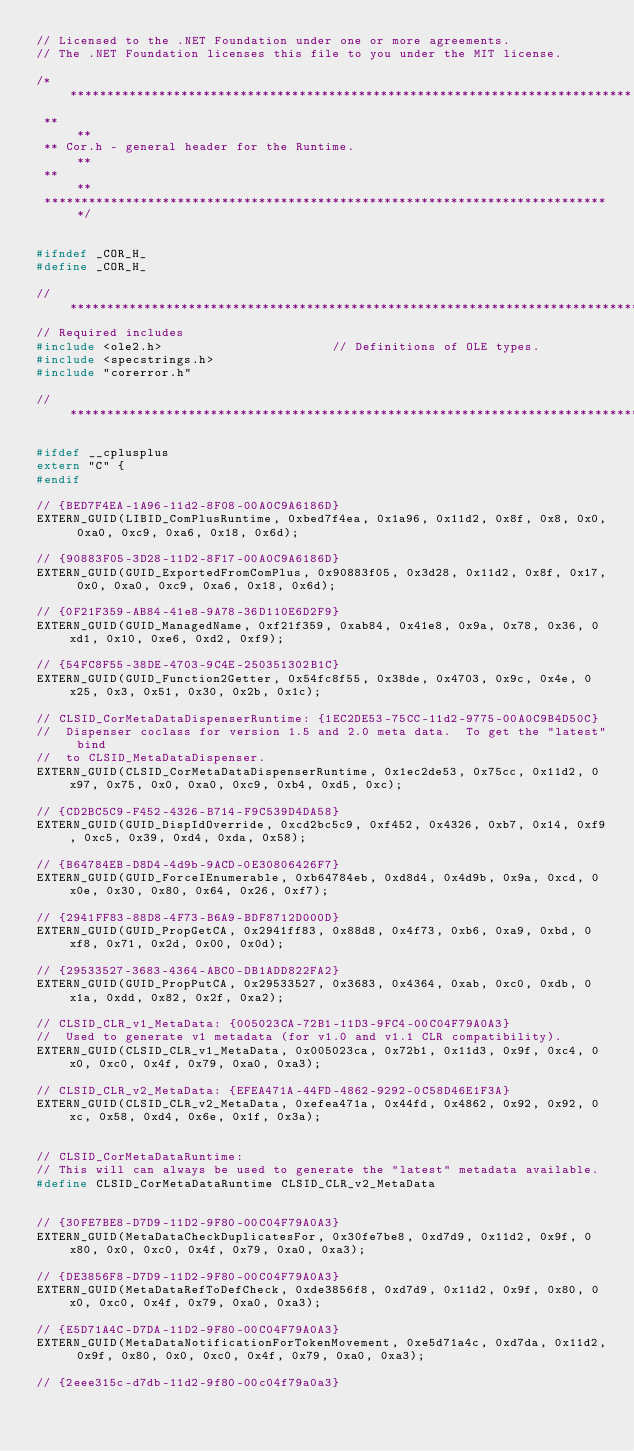Convert code to text. <code><loc_0><loc_0><loc_500><loc_500><_C_>// Licensed to the .NET Foundation under one or more agreements.
// The .NET Foundation licenses this file to you under the MIT license.

/*****************************************************************************
 **                                                                         **
 ** Cor.h - general header for the Runtime.                                 **
 **                                                                         **
 *****************************************************************************/


#ifndef _COR_H_
#define _COR_H_

//*****************************************************************************
// Required includes
#include <ole2.h>                       // Definitions of OLE types.
#include <specstrings.h>
#include "corerror.h"

//*****************************************************************************

#ifdef __cplusplus
extern "C" {
#endif

// {BED7F4EA-1A96-11d2-8F08-00A0C9A6186D}
EXTERN_GUID(LIBID_ComPlusRuntime, 0xbed7f4ea, 0x1a96, 0x11d2, 0x8f, 0x8, 0x0, 0xa0, 0xc9, 0xa6, 0x18, 0x6d);

// {90883F05-3D28-11D2-8F17-00A0C9A6186D}
EXTERN_GUID(GUID_ExportedFromComPlus, 0x90883f05, 0x3d28, 0x11d2, 0x8f, 0x17, 0x0, 0xa0, 0xc9, 0xa6, 0x18, 0x6d);

// {0F21F359-AB84-41e8-9A78-36D110E6D2F9}
EXTERN_GUID(GUID_ManagedName, 0xf21f359, 0xab84, 0x41e8, 0x9a, 0x78, 0x36, 0xd1, 0x10, 0xe6, 0xd2, 0xf9);

// {54FC8F55-38DE-4703-9C4E-250351302B1C}
EXTERN_GUID(GUID_Function2Getter, 0x54fc8f55, 0x38de, 0x4703, 0x9c, 0x4e, 0x25, 0x3, 0x51, 0x30, 0x2b, 0x1c);

// CLSID_CorMetaDataDispenserRuntime: {1EC2DE53-75CC-11d2-9775-00A0C9B4D50C}
//  Dispenser coclass for version 1.5 and 2.0 meta data.  To get the "latest" bind
//  to CLSID_MetaDataDispenser.
EXTERN_GUID(CLSID_CorMetaDataDispenserRuntime, 0x1ec2de53, 0x75cc, 0x11d2, 0x97, 0x75, 0x0, 0xa0, 0xc9, 0xb4, 0xd5, 0xc);

// {CD2BC5C9-F452-4326-B714-F9C539D4DA58}
EXTERN_GUID(GUID_DispIdOverride, 0xcd2bc5c9, 0xf452, 0x4326, 0xb7, 0x14, 0xf9, 0xc5, 0x39, 0xd4, 0xda, 0x58);

// {B64784EB-D8D4-4d9b-9ACD-0E30806426F7}
EXTERN_GUID(GUID_ForceIEnumerable, 0xb64784eb, 0xd8d4, 0x4d9b, 0x9a, 0xcd, 0x0e, 0x30, 0x80, 0x64, 0x26, 0xf7);

// {2941FF83-88D8-4F73-B6A9-BDF8712D000D}
EXTERN_GUID(GUID_PropGetCA, 0x2941ff83, 0x88d8, 0x4f73, 0xb6, 0xa9, 0xbd, 0xf8, 0x71, 0x2d, 0x00, 0x0d);

// {29533527-3683-4364-ABC0-DB1ADD822FA2}
EXTERN_GUID(GUID_PropPutCA, 0x29533527, 0x3683, 0x4364, 0xab, 0xc0, 0xdb, 0x1a, 0xdd, 0x82, 0x2f, 0xa2);

// CLSID_CLR_v1_MetaData: {005023CA-72B1-11D3-9FC4-00C04F79A0A3}
//  Used to generate v1 metadata (for v1.0 and v1.1 CLR compatibility).
EXTERN_GUID(CLSID_CLR_v1_MetaData, 0x005023ca, 0x72b1, 0x11d3, 0x9f, 0xc4, 0x0, 0xc0, 0x4f, 0x79, 0xa0, 0xa3);

// CLSID_CLR_v2_MetaData: {EFEA471A-44FD-4862-9292-0C58D46E1F3A}
EXTERN_GUID(CLSID_CLR_v2_MetaData, 0xefea471a, 0x44fd, 0x4862, 0x92, 0x92, 0xc, 0x58, 0xd4, 0x6e, 0x1f, 0x3a);


// CLSID_CorMetaDataRuntime:
// This will can always be used to generate the "latest" metadata available.
#define CLSID_CorMetaDataRuntime CLSID_CLR_v2_MetaData


// {30FE7BE8-D7D9-11D2-9F80-00C04F79A0A3}
EXTERN_GUID(MetaDataCheckDuplicatesFor, 0x30fe7be8, 0xd7d9, 0x11d2, 0x9f, 0x80, 0x0, 0xc0, 0x4f, 0x79, 0xa0, 0xa3);

// {DE3856F8-D7D9-11D2-9F80-00C04F79A0A3}
EXTERN_GUID(MetaDataRefToDefCheck, 0xde3856f8, 0xd7d9, 0x11d2, 0x9f, 0x80, 0x0, 0xc0, 0x4f, 0x79, 0xa0, 0xa3);

// {E5D71A4C-D7DA-11D2-9F80-00C04F79A0A3}
EXTERN_GUID(MetaDataNotificationForTokenMovement, 0xe5d71a4c, 0xd7da, 0x11d2, 0x9f, 0x80, 0x0, 0xc0, 0x4f, 0x79, 0xa0, 0xa3);

// {2eee315c-d7db-11d2-9f80-00c04f79a0a3}</code> 